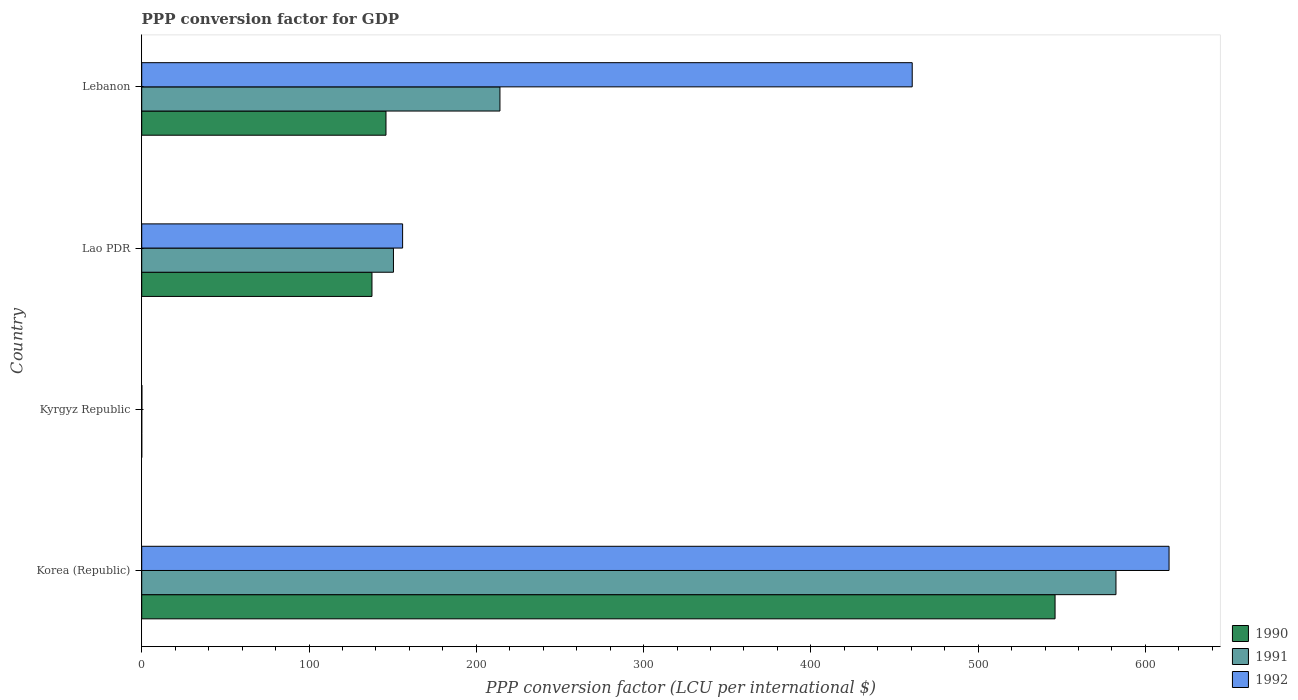Are the number of bars per tick equal to the number of legend labels?
Ensure brevity in your answer.  Yes. How many bars are there on the 3rd tick from the bottom?
Make the answer very short. 3. What is the label of the 3rd group of bars from the top?
Make the answer very short. Kyrgyz Republic. What is the PPP conversion factor for GDP in 1991 in Korea (Republic)?
Your response must be concise. 582.39. Across all countries, what is the maximum PPP conversion factor for GDP in 1992?
Make the answer very short. 614.12. Across all countries, what is the minimum PPP conversion factor for GDP in 1992?
Your answer should be compact. 0.09. In which country was the PPP conversion factor for GDP in 1990 minimum?
Give a very brief answer. Kyrgyz Republic. What is the total PPP conversion factor for GDP in 1992 in the graph?
Give a very brief answer. 1230.75. What is the difference between the PPP conversion factor for GDP in 1990 in Kyrgyz Republic and that in Lebanon?
Provide a short and direct response. -146.01. What is the difference between the PPP conversion factor for GDP in 1992 in Lao PDR and the PPP conversion factor for GDP in 1991 in Korea (Republic)?
Your response must be concise. -426.44. What is the average PPP conversion factor for GDP in 1992 per country?
Your answer should be compact. 307.69. What is the difference between the PPP conversion factor for GDP in 1991 and PPP conversion factor for GDP in 1990 in Korea (Republic)?
Keep it short and to the point. 36.41. In how many countries, is the PPP conversion factor for GDP in 1990 greater than 420 LCU?
Provide a succinct answer. 1. What is the ratio of the PPP conversion factor for GDP in 1991 in Lao PDR to that in Lebanon?
Your response must be concise. 0.7. Is the difference between the PPP conversion factor for GDP in 1991 in Korea (Republic) and Kyrgyz Republic greater than the difference between the PPP conversion factor for GDP in 1990 in Korea (Republic) and Kyrgyz Republic?
Make the answer very short. Yes. What is the difference between the highest and the second highest PPP conversion factor for GDP in 1990?
Provide a short and direct response. 399.96. What is the difference between the highest and the lowest PPP conversion factor for GDP in 1991?
Provide a succinct answer. 582.38. In how many countries, is the PPP conversion factor for GDP in 1990 greater than the average PPP conversion factor for GDP in 1990 taken over all countries?
Your answer should be very brief. 1. Is the sum of the PPP conversion factor for GDP in 1991 in Kyrgyz Republic and Lebanon greater than the maximum PPP conversion factor for GDP in 1990 across all countries?
Provide a succinct answer. No. What does the 1st bar from the top in Lao PDR represents?
Provide a succinct answer. 1992. Is it the case that in every country, the sum of the PPP conversion factor for GDP in 1992 and PPP conversion factor for GDP in 1990 is greater than the PPP conversion factor for GDP in 1991?
Offer a very short reply. Yes. How many bars are there?
Give a very brief answer. 12. Are all the bars in the graph horizontal?
Ensure brevity in your answer.  Yes. Where does the legend appear in the graph?
Give a very brief answer. Bottom right. How are the legend labels stacked?
Your answer should be compact. Vertical. What is the title of the graph?
Your response must be concise. PPP conversion factor for GDP. Does "1961" appear as one of the legend labels in the graph?
Give a very brief answer. No. What is the label or title of the X-axis?
Keep it short and to the point. PPP conversion factor (LCU per international $). What is the label or title of the Y-axis?
Provide a succinct answer. Country. What is the PPP conversion factor (LCU per international $) in 1990 in Korea (Republic)?
Your answer should be very brief. 545.98. What is the PPP conversion factor (LCU per international $) of 1991 in Korea (Republic)?
Make the answer very short. 582.39. What is the PPP conversion factor (LCU per international $) in 1992 in Korea (Republic)?
Your answer should be compact. 614.12. What is the PPP conversion factor (LCU per international $) in 1990 in Kyrgyz Republic?
Offer a terse response. 0. What is the PPP conversion factor (LCU per international $) of 1991 in Kyrgyz Republic?
Provide a short and direct response. 0.01. What is the PPP conversion factor (LCU per international $) in 1992 in Kyrgyz Republic?
Ensure brevity in your answer.  0.09. What is the PPP conversion factor (LCU per international $) of 1990 in Lao PDR?
Give a very brief answer. 137.64. What is the PPP conversion factor (LCU per international $) in 1991 in Lao PDR?
Provide a short and direct response. 150.48. What is the PPP conversion factor (LCU per international $) of 1992 in Lao PDR?
Provide a succinct answer. 155.95. What is the PPP conversion factor (LCU per international $) of 1990 in Lebanon?
Ensure brevity in your answer.  146.02. What is the PPP conversion factor (LCU per international $) of 1991 in Lebanon?
Your answer should be very brief. 214.14. What is the PPP conversion factor (LCU per international $) in 1992 in Lebanon?
Provide a short and direct response. 460.59. Across all countries, what is the maximum PPP conversion factor (LCU per international $) of 1990?
Offer a very short reply. 545.98. Across all countries, what is the maximum PPP conversion factor (LCU per international $) in 1991?
Provide a succinct answer. 582.39. Across all countries, what is the maximum PPP conversion factor (LCU per international $) of 1992?
Provide a succinct answer. 614.12. Across all countries, what is the minimum PPP conversion factor (LCU per international $) in 1990?
Your response must be concise. 0. Across all countries, what is the minimum PPP conversion factor (LCU per international $) in 1991?
Keep it short and to the point. 0.01. Across all countries, what is the minimum PPP conversion factor (LCU per international $) of 1992?
Give a very brief answer. 0.09. What is the total PPP conversion factor (LCU per international $) in 1990 in the graph?
Provide a succinct answer. 829.64. What is the total PPP conversion factor (LCU per international $) in 1991 in the graph?
Offer a very short reply. 947.02. What is the total PPP conversion factor (LCU per international $) of 1992 in the graph?
Give a very brief answer. 1230.75. What is the difference between the PPP conversion factor (LCU per international $) in 1990 in Korea (Republic) and that in Kyrgyz Republic?
Keep it short and to the point. 545.98. What is the difference between the PPP conversion factor (LCU per international $) in 1991 in Korea (Republic) and that in Kyrgyz Republic?
Offer a very short reply. 582.38. What is the difference between the PPP conversion factor (LCU per international $) in 1992 in Korea (Republic) and that in Kyrgyz Republic?
Give a very brief answer. 614.04. What is the difference between the PPP conversion factor (LCU per international $) in 1990 in Korea (Republic) and that in Lao PDR?
Give a very brief answer. 408.34. What is the difference between the PPP conversion factor (LCU per international $) of 1991 in Korea (Republic) and that in Lao PDR?
Make the answer very short. 431.9. What is the difference between the PPP conversion factor (LCU per international $) of 1992 in Korea (Republic) and that in Lao PDR?
Ensure brevity in your answer.  458.18. What is the difference between the PPP conversion factor (LCU per international $) of 1990 in Korea (Republic) and that in Lebanon?
Your response must be concise. 399.96. What is the difference between the PPP conversion factor (LCU per international $) of 1991 in Korea (Republic) and that in Lebanon?
Offer a very short reply. 368.25. What is the difference between the PPP conversion factor (LCU per international $) in 1992 in Korea (Republic) and that in Lebanon?
Your response must be concise. 153.54. What is the difference between the PPP conversion factor (LCU per international $) in 1990 in Kyrgyz Republic and that in Lao PDR?
Your response must be concise. -137.63. What is the difference between the PPP conversion factor (LCU per international $) in 1991 in Kyrgyz Republic and that in Lao PDR?
Ensure brevity in your answer.  -150.47. What is the difference between the PPP conversion factor (LCU per international $) of 1992 in Kyrgyz Republic and that in Lao PDR?
Provide a succinct answer. -155.86. What is the difference between the PPP conversion factor (LCU per international $) in 1990 in Kyrgyz Republic and that in Lebanon?
Your response must be concise. -146.01. What is the difference between the PPP conversion factor (LCU per international $) in 1991 in Kyrgyz Republic and that in Lebanon?
Keep it short and to the point. -214.13. What is the difference between the PPP conversion factor (LCU per international $) in 1992 in Kyrgyz Republic and that in Lebanon?
Give a very brief answer. -460.5. What is the difference between the PPP conversion factor (LCU per international $) in 1990 in Lao PDR and that in Lebanon?
Offer a very short reply. -8.38. What is the difference between the PPP conversion factor (LCU per international $) in 1991 in Lao PDR and that in Lebanon?
Give a very brief answer. -63.66. What is the difference between the PPP conversion factor (LCU per international $) of 1992 in Lao PDR and that in Lebanon?
Provide a succinct answer. -304.64. What is the difference between the PPP conversion factor (LCU per international $) of 1990 in Korea (Republic) and the PPP conversion factor (LCU per international $) of 1991 in Kyrgyz Republic?
Offer a terse response. 545.97. What is the difference between the PPP conversion factor (LCU per international $) of 1990 in Korea (Republic) and the PPP conversion factor (LCU per international $) of 1992 in Kyrgyz Republic?
Make the answer very short. 545.89. What is the difference between the PPP conversion factor (LCU per international $) in 1991 in Korea (Republic) and the PPP conversion factor (LCU per international $) in 1992 in Kyrgyz Republic?
Your answer should be very brief. 582.3. What is the difference between the PPP conversion factor (LCU per international $) in 1990 in Korea (Republic) and the PPP conversion factor (LCU per international $) in 1991 in Lao PDR?
Make the answer very short. 395.5. What is the difference between the PPP conversion factor (LCU per international $) of 1990 in Korea (Republic) and the PPP conversion factor (LCU per international $) of 1992 in Lao PDR?
Make the answer very short. 390.03. What is the difference between the PPP conversion factor (LCU per international $) of 1991 in Korea (Republic) and the PPP conversion factor (LCU per international $) of 1992 in Lao PDR?
Your answer should be compact. 426.44. What is the difference between the PPP conversion factor (LCU per international $) of 1990 in Korea (Republic) and the PPP conversion factor (LCU per international $) of 1991 in Lebanon?
Provide a succinct answer. 331.84. What is the difference between the PPP conversion factor (LCU per international $) in 1990 in Korea (Republic) and the PPP conversion factor (LCU per international $) in 1992 in Lebanon?
Provide a succinct answer. 85.39. What is the difference between the PPP conversion factor (LCU per international $) of 1991 in Korea (Republic) and the PPP conversion factor (LCU per international $) of 1992 in Lebanon?
Keep it short and to the point. 121.8. What is the difference between the PPP conversion factor (LCU per international $) in 1990 in Kyrgyz Republic and the PPP conversion factor (LCU per international $) in 1991 in Lao PDR?
Your response must be concise. -150.48. What is the difference between the PPP conversion factor (LCU per international $) of 1990 in Kyrgyz Republic and the PPP conversion factor (LCU per international $) of 1992 in Lao PDR?
Your answer should be very brief. -155.94. What is the difference between the PPP conversion factor (LCU per international $) of 1991 in Kyrgyz Republic and the PPP conversion factor (LCU per international $) of 1992 in Lao PDR?
Your answer should be very brief. -155.94. What is the difference between the PPP conversion factor (LCU per international $) of 1990 in Kyrgyz Republic and the PPP conversion factor (LCU per international $) of 1991 in Lebanon?
Your response must be concise. -214.14. What is the difference between the PPP conversion factor (LCU per international $) of 1990 in Kyrgyz Republic and the PPP conversion factor (LCU per international $) of 1992 in Lebanon?
Ensure brevity in your answer.  -460.58. What is the difference between the PPP conversion factor (LCU per international $) of 1991 in Kyrgyz Republic and the PPP conversion factor (LCU per international $) of 1992 in Lebanon?
Provide a short and direct response. -460.58. What is the difference between the PPP conversion factor (LCU per international $) of 1990 in Lao PDR and the PPP conversion factor (LCU per international $) of 1991 in Lebanon?
Offer a very short reply. -76.5. What is the difference between the PPP conversion factor (LCU per international $) of 1990 in Lao PDR and the PPP conversion factor (LCU per international $) of 1992 in Lebanon?
Ensure brevity in your answer.  -322.95. What is the difference between the PPP conversion factor (LCU per international $) of 1991 in Lao PDR and the PPP conversion factor (LCU per international $) of 1992 in Lebanon?
Your response must be concise. -310.1. What is the average PPP conversion factor (LCU per international $) in 1990 per country?
Your answer should be very brief. 207.41. What is the average PPP conversion factor (LCU per international $) of 1991 per country?
Keep it short and to the point. 236.76. What is the average PPP conversion factor (LCU per international $) in 1992 per country?
Give a very brief answer. 307.69. What is the difference between the PPP conversion factor (LCU per international $) in 1990 and PPP conversion factor (LCU per international $) in 1991 in Korea (Republic)?
Offer a very short reply. -36.41. What is the difference between the PPP conversion factor (LCU per international $) of 1990 and PPP conversion factor (LCU per international $) of 1992 in Korea (Republic)?
Your response must be concise. -68.14. What is the difference between the PPP conversion factor (LCU per international $) of 1991 and PPP conversion factor (LCU per international $) of 1992 in Korea (Republic)?
Provide a succinct answer. -31.74. What is the difference between the PPP conversion factor (LCU per international $) in 1990 and PPP conversion factor (LCU per international $) in 1991 in Kyrgyz Republic?
Make the answer very short. -0.01. What is the difference between the PPP conversion factor (LCU per international $) of 1990 and PPP conversion factor (LCU per international $) of 1992 in Kyrgyz Republic?
Your response must be concise. -0.09. What is the difference between the PPP conversion factor (LCU per international $) in 1991 and PPP conversion factor (LCU per international $) in 1992 in Kyrgyz Republic?
Make the answer very short. -0.08. What is the difference between the PPP conversion factor (LCU per international $) of 1990 and PPP conversion factor (LCU per international $) of 1991 in Lao PDR?
Give a very brief answer. -12.85. What is the difference between the PPP conversion factor (LCU per international $) of 1990 and PPP conversion factor (LCU per international $) of 1992 in Lao PDR?
Your response must be concise. -18.31. What is the difference between the PPP conversion factor (LCU per international $) in 1991 and PPP conversion factor (LCU per international $) in 1992 in Lao PDR?
Provide a succinct answer. -5.46. What is the difference between the PPP conversion factor (LCU per international $) of 1990 and PPP conversion factor (LCU per international $) of 1991 in Lebanon?
Provide a short and direct response. -68.13. What is the difference between the PPP conversion factor (LCU per international $) in 1990 and PPP conversion factor (LCU per international $) in 1992 in Lebanon?
Make the answer very short. -314.57. What is the difference between the PPP conversion factor (LCU per international $) in 1991 and PPP conversion factor (LCU per international $) in 1992 in Lebanon?
Your answer should be very brief. -246.45. What is the ratio of the PPP conversion factor (LCU per international $) of 1990 in Korea (Republic) to that in Kyrgyz Republic?
Your answer should be compact. 1.26e+05. What is the ratio of the PPP conversion factor (LCU per international $) of 1991 in Korea (Republic) to that in Kyrgyz Republic?
Provide a short and direct response. 5.91e+04. What is the ratio of the PPP conversion factor (LCU per international $) in 1992 in Korea (Republic) to that in Kyrgyz Republic?
Your response must be concise. 6851.33. What is the ratio of the PPP conversion factor (LCU per international $) of 1990 in Korea (Republic) to that in Lao PDR?
Offer a very short reply. 3.97. What is the ratio of the PPP conversion factor (LCU per international $) of 1991 in Korea (Republic) to that in Lao PDR?
Offer a terse response. 3.87. What is the ratio of the PPP conversion factor (LCU per international $) of 1992 in Korea (Republic) to that in Lao PDR?
Your answer should be very brief. 3.94. What is the ratio of the PPP conversion factor (LCU per international $) in 1990 in Korea (Republic) to that in Lebanon?
Provide a succinct answer. 3.74. What is the ratio of the PPP conversion factor (LCU per international $) in 1991 in Korea (Republic) to that in Lebanon?
Your answer should be very brief. 2.72. What is the ratio of the PPP conversion factor (LCU per international $) of 1990 in Kyrgyz Republic to that in Lao PDR?
Keep it short and to the point. 0. What is the ratio of the PPP conversion factor (LCU per international $) of 1992 in Kyrgyz Republic to that in Lao PDR?
Provide a succinct answer. 0. What is the ratio of the PPP conversion factor (LCU per international $) of 1992 in Kyrgyz Republic to that in Lebanon?
Ensure brevity in your answer.  0. What is the ratio of the PPP conversion factor (LCU per international $) in 1990 in Lao PDR to that in Lebanon?
Your answer should be very brief. 0.94. What is the ratio of the PPP conversion factor (LCU per international $) of 1991 in Lao PDR to that in Lebanon?
Ensure brevity in your answer.  0.7. What is the ratio of the PPP conversion factor (LCU per international $) in 1992 in Lao PDR to that in Lebanon?
Provide a succinct answer. 0.34. What is the difference between the highest and the second highest PPP conversion factor (LCU per international $) of 1990?
Provide a short and direct response. 399.96. What is the difference between the highest and the second highest PPP conversion factor (LCU per international $) of 1991?
Ensure brevity in your answer.  368.25. What is the difference between the highest and the second highest PPP conversion factor (LCU per international $) in 1992?
Provide a short and direct response. 153.54. What is the difference between the highest and the lowest PPP conversion factor (LCU per international $) of 1990?
Provide a succinct answer. 545.98. What is the difference between the highest and the lowest PPP conversion factor (LCU per international $) of 1991?
Provide a succinct answer. 582.38. What is the difference between the highest and the lowest PPP conversion factor (LCU per international $) in 1992?
Make the answer very short. 614.04. 